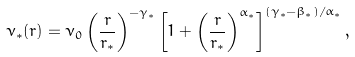Convert formula to latex. <formula><loc_0><loc_0><loc_500><loc_500>\nu _ { * } ( r ) = \nu _ { 0 } \left ( \frac { r } { r _ { * } } \right ) ^ { - \gamma _ { * } } \left [ 1 + \left ( \frac { r } { r _ { * } } \right ) ^ { \alpha _ { * } } \right ] ^ { ( \gamma _ { * } - \beta _ { * } ) / \alpha _ { * } } ,</formula> 